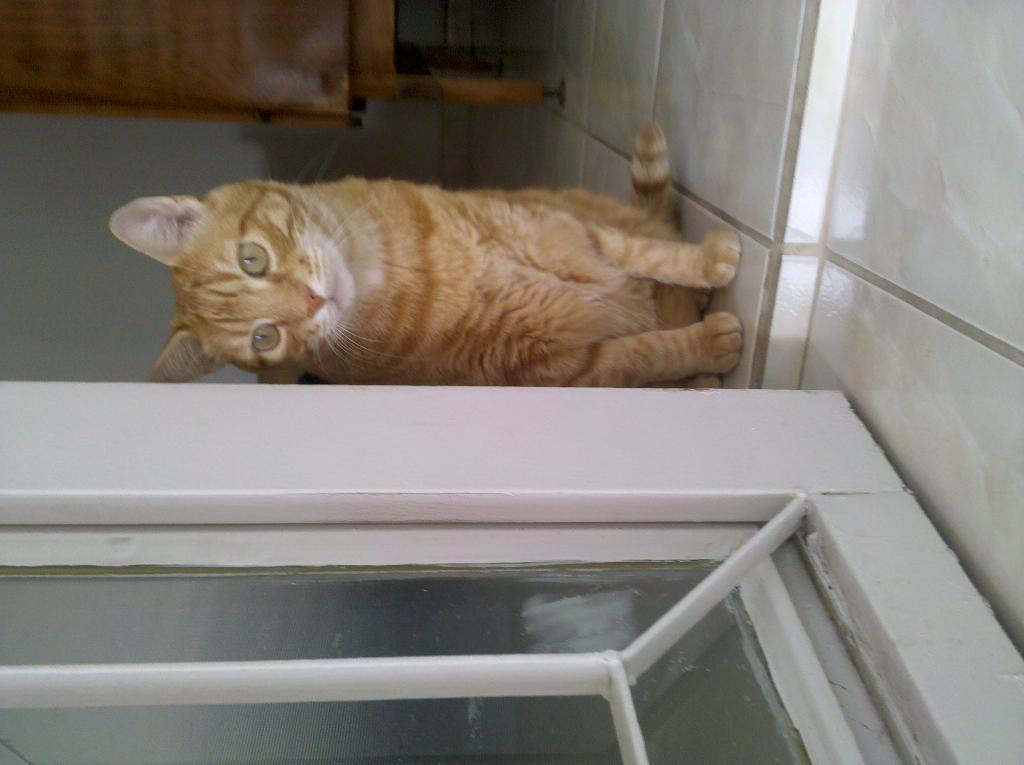What animal can be seen sitting on the floor in the image? There is a cat sitting on the floor in the image. What type of door and grill are visible at the bottom of the image? There is a glass door and grill at the bottom of the image. What can be seen in the background of the image? There is a wall and a wooden piece in the background of the image. What type of celery is being used as a decoration in the image? There is no celery present in the image; it is a cat sitting on the floor, with a glass door and grill, and a wall and wooden piece in the background. 